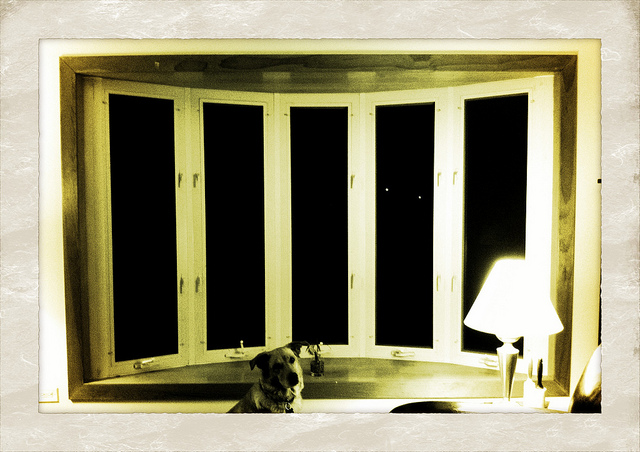<image>Was the person taking this picture tall? It is unknown if the person taking this picture was tall or not. Was the person taking this picture tall? I don't know if the person taking this picture was tall. It is possible, but I am not sure. 